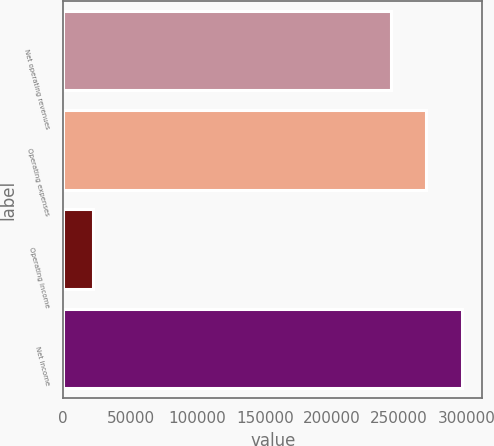Convert chart. <chart><loc_0><loc_0><loc_500><loc_500><bar_chart><fcel>Net operating revenues<fcel>Operating expenses<fcel>Operating income<fcel>Net income<nl><fcel>243652<fcel>270341<fcel>22089<fcel>297030<nl></chart> 